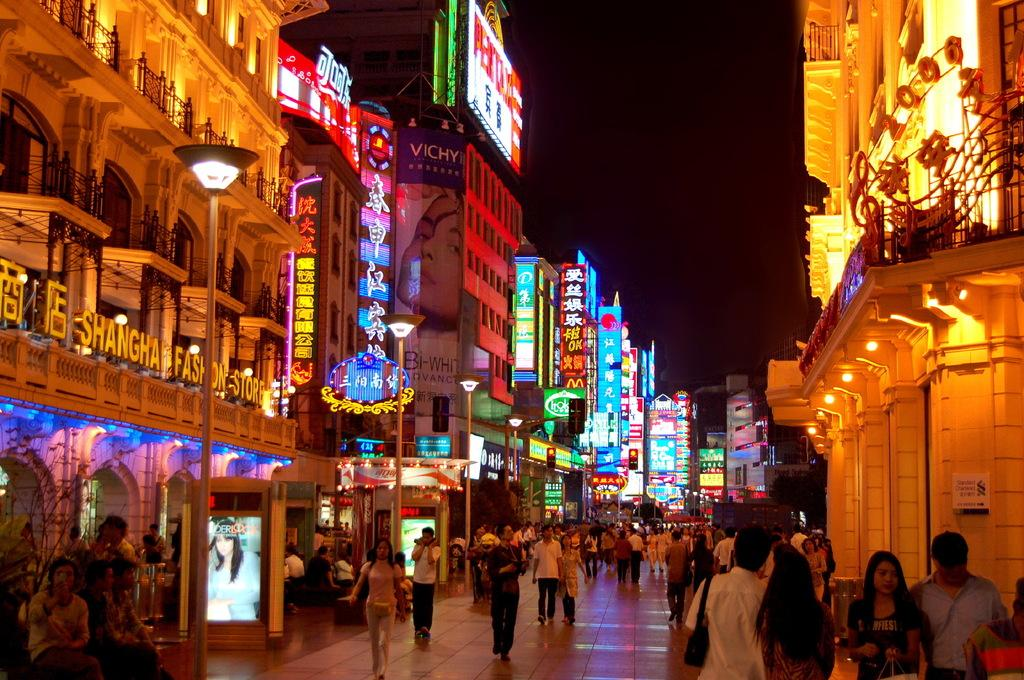<image>
Summarize the visual content of the image. People are walking on a street between neon lit signs on buildings at night and the Shanghai Fashion Store is to the left. 